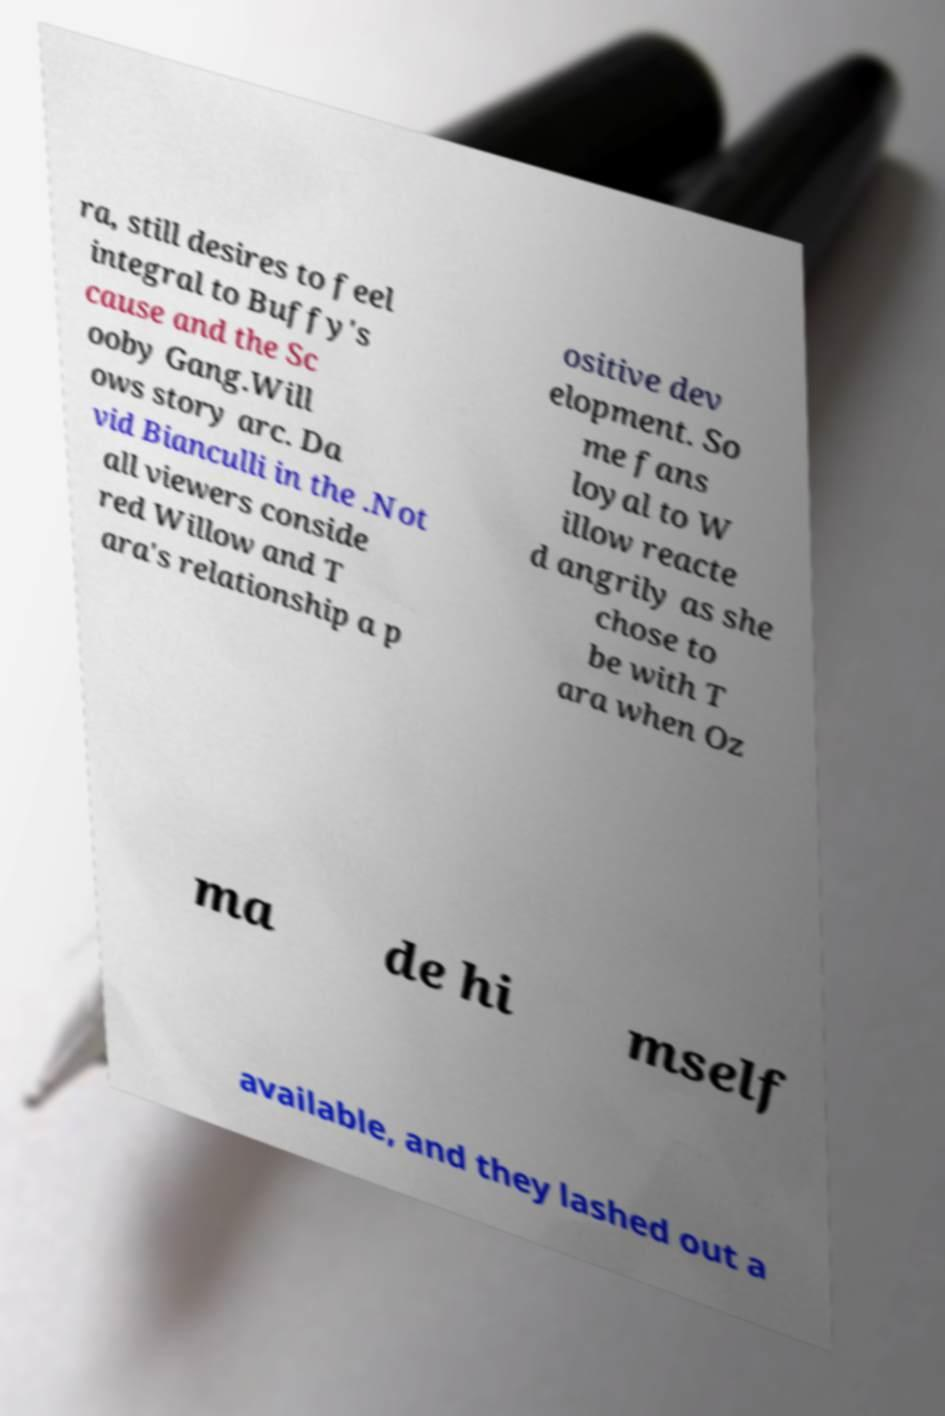Please identify and transcribe the text found in this image. ra, still desires to feel integral to Buffy's cause and the Sc ooby Gang.Will ows story arc. Da vid Bianculli in the .Not all viewers conside red Willow and T ara's relationship a p ositive dev elopment. So me fans loyal to W illow reacte d angrily as she chose to be with T ara when Oz ma de hi mself available, and they lashed out a 